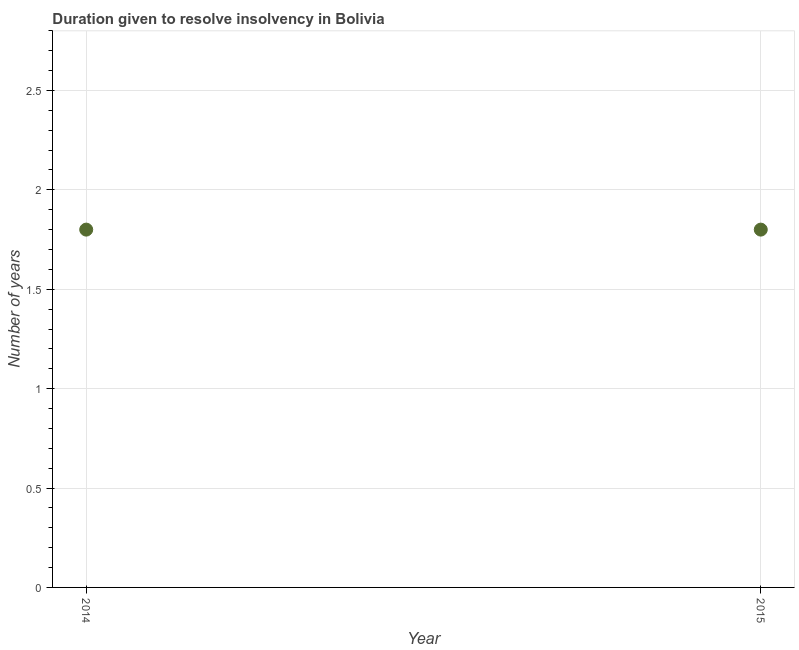In which year was the number of years to resolve insolvency minimum?
Offer a very short reply. 2014. What is the average number of years to resolve insolvency per year?
Ensure brevity in your answer.  1.8. Do a majority of the years between 2015 and 2014 (inclusive) have number of years to resolve insolvency greater than 0.4 ?
Give a very brief answer. No. In how many years, is the number of years to resolve insolvency greater than the average number of years to resolve insolvency taken over all years?
Provide a short and direct response. 0. Does the number of years to resolve insolvency monotonically increase over the years?
Your answer should be very brief. No. How many dotlines are there?
Ensure brevity in your answer.  1. What is the difference between two consecutive major ticks on the Y-axis?
Your answer should be very brief. 0.5. Does the graph contain grids?
Ensure brevity in your answer.  Yes. What is the title of the graph?
Ensure brevity in your answer.  Duration given to resolve insolvency in Bolivia. What is the label or title of the X-axis?
Offer a terse response. Year. What is the label or title of the Y-axis?
Your answer should be very brief. Number of years. What is the Number of years in 2015?
Your answer should be compact. 1.8. What is the difference between the Number of years in 2014 and 2015?
Provide a short and direct response. 0. 